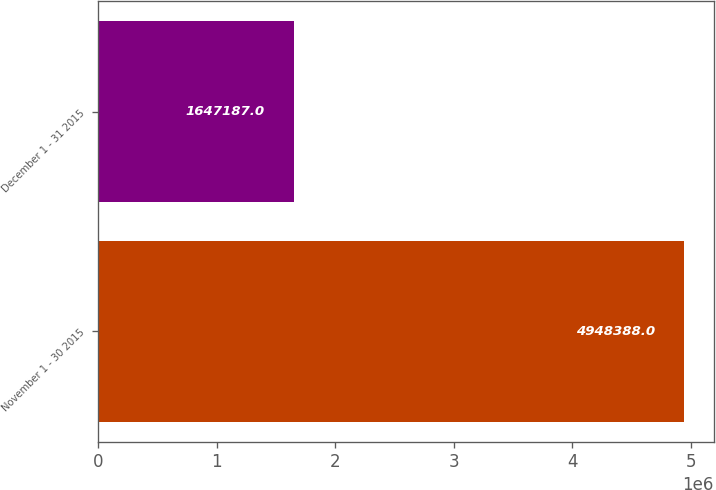<chart> <loc_0><loc_0><loc_500><loc_500><bar_chart><fcel>November 1 - 30 2015<fcel>December 1 - 31 2015<nl><fcel>4.94839e+06<fcel>1.64719e+06<nl></chart> 